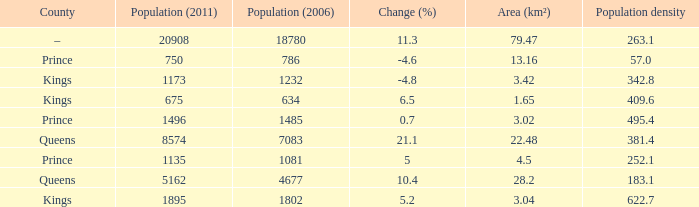What is the Population density that has a Change (%) higher than 10.4, and a Population (2011) less than 8574, in the County of Queens? None. Can you give me this table as a dict? {'header': ['County', 'Population (2011)', 'Population (2006)', 'Change (%)', 'Area (km²)', 'Population density'], 'rows': [['–', '20908', '18780', '11.3', '79.47', '263.1'], ['Prince', '750', '786', '-4.6', '13.16', '57.0'], ['Kings', '1173', '1232', '-4.8', '3.42', '342.8'], ['Kings', '675', '634', '6.5', '1.65', '409.6'], ['Prince', '1496', '1485', '0.7', '3.02', '495.4'], ['Queens', '8574', '7083', '21.1', '22.48', '381.4'], ['Prince', '1135', '1081', '5', '4.5', '252.1'], ['Queens', '5162', '4677', '10.4', '28.2', '183.1'], ['Kings', '1895', '1802', '5.2', '3.04', '622.7']]} 